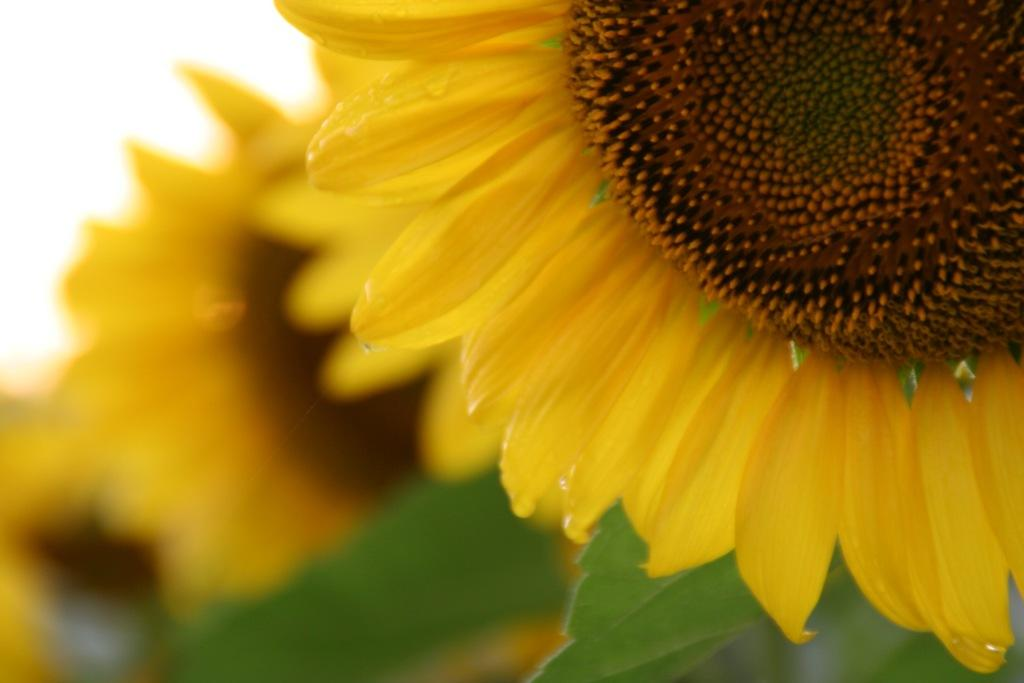What type of living organisms can be seen in the image? There are flowers in the image. What type of leather is used to make the doll in the image? There is no doll present in the image, and therefore no leather can be associated with it. 